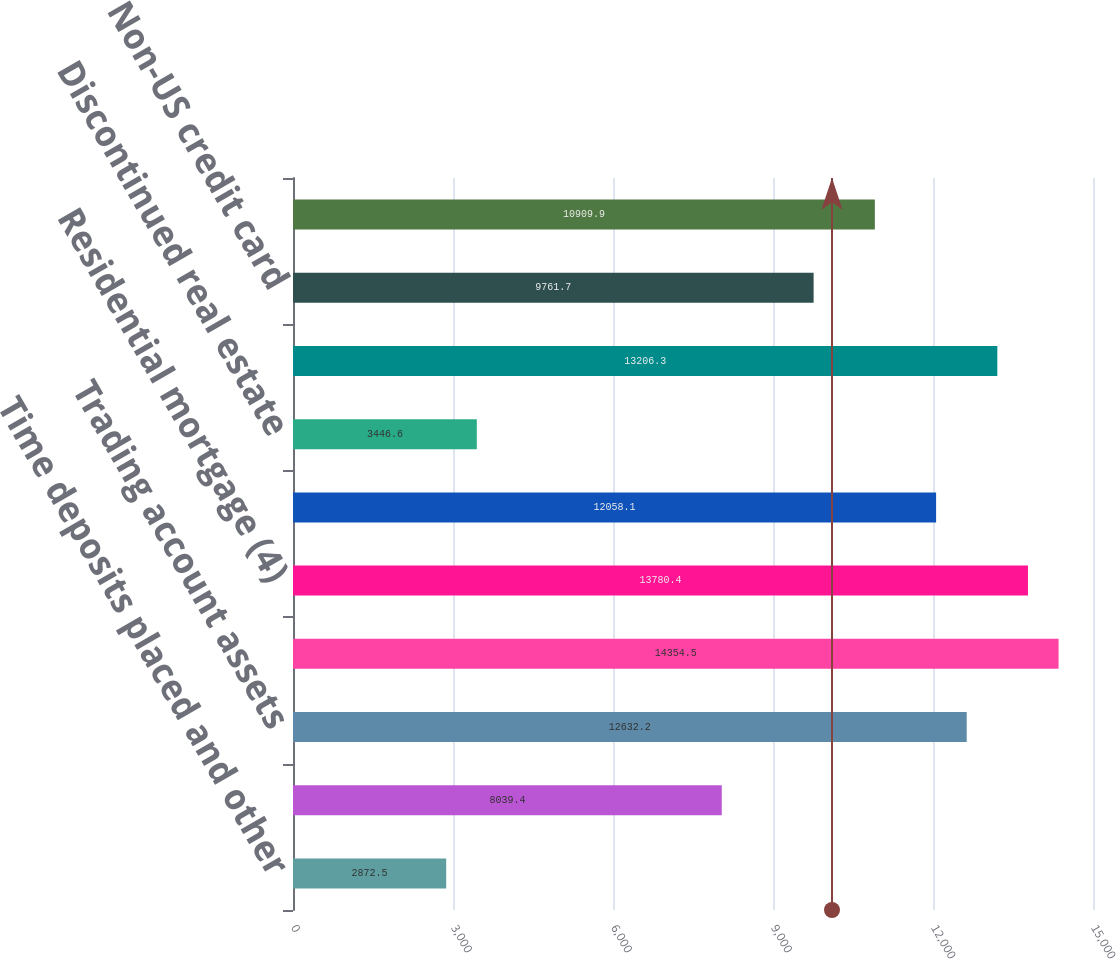Convert chart to OTSL. <chart><loc_0><loc_0><loc_500><loc_500><bar_chart><fcel>Time deposits placed and other<fcel>Federal funds sold and<fcel>Trading account assets<fcel>Debt securities (2)<fcel>Residential mortgage (4)<fcel>Home equity<fcel>Discontinued real estate<fcel>US credit card<fcel>Non-US credit card<fcel>Direct/Indirect consumer (5)<nl><fcel>2872.5<fcel>8039.4<fcel>12632.2<fcel>14354.5<fcel>13780.4<fcel>12058.1<fcel>3446.6<fcel>13206.3<fcel>9761.7<fcel>10909.9<nl></chart> 